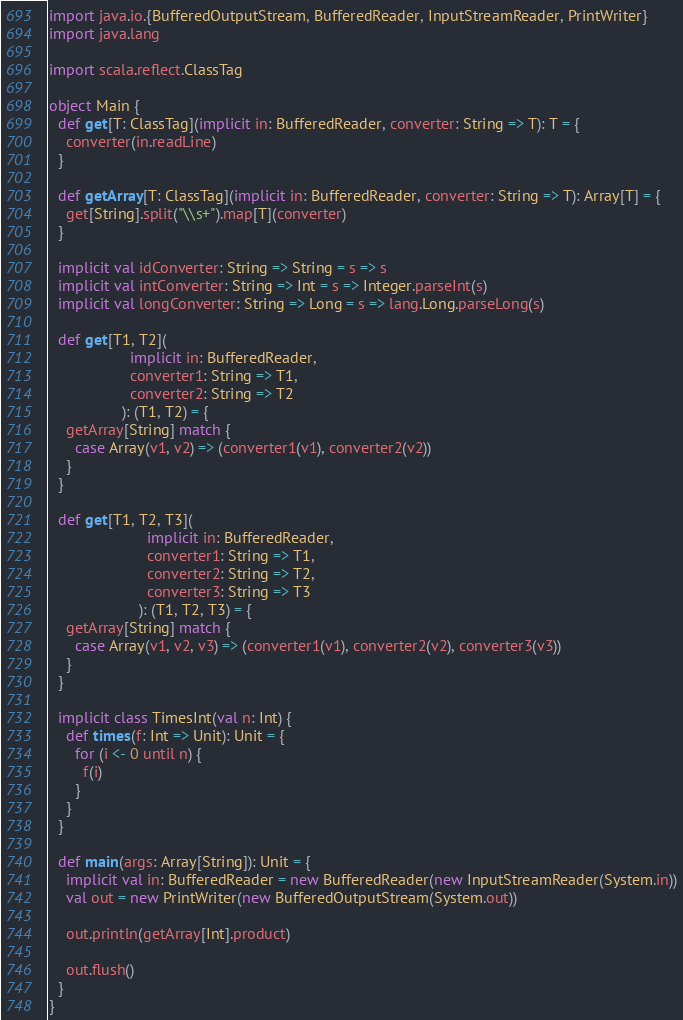<code> <loc_0><loc_0><loc_500><loc_500><_Scala_>import java.io.{BufferedOutputStream, BufferedReader, InputStreamReader, PrintWriter}
import java.lang

import scala.reflect.ClassTag

object Main {
  def get[T: ClassTag](implicit in: BufferedReader, converter: String => T): T = {
    converter(in.readLine)
  }

  def getArray[T: ClassTag](implicit in: BufferedReader, converter: String => T): Array[T] = {
    get[String].split("\\s+").map[T](converter)
  }

  implicit val idConverter: String => String = s => s
  implicit val intConverter: String => Int = s => Integer.parseInt(s)
  implicit val longConverter: String => Long = s => lang.Long.parseLong(s)

  def get[T1, T2](
                   implicit in: BufferedReader,
                   converter1: String => T1,
                   converter2: String => T2
                 ): (T1, T2) = {
    getArray[String] match {
      case Array(v1, v2) => (converter1(v1), converter2(v2))
    }
  }

  def get[T1, T2, T3](
                       implicit in: BufferedReader,
                       converter1: String => T1,
                       converter2: String => T2,
                       converter3: String => T3
                     ): (T1, T2, T3) = {
    getArray[String] match {
      case Array(v1, v2, v3) => (converter1(v1), converter2(v2), converter3(v3))
    }
  }

  implicit class TimesInt(val n: Int) {
    def times(f: Int => Unit): Unit = {
      for (i <- 0 until n) {
        f(i)
      }
    }
  }

  def main(args: Array[String]): Unit = {
    implicit val in: BufferedReader = new BufferedReader(new InputStreamReader(System.in))
    val out = new PrintWriter(new BufferedOutputStream(System.out))

    out.println(getArray[Int].product)

    out.flush()
  }
}</code> 